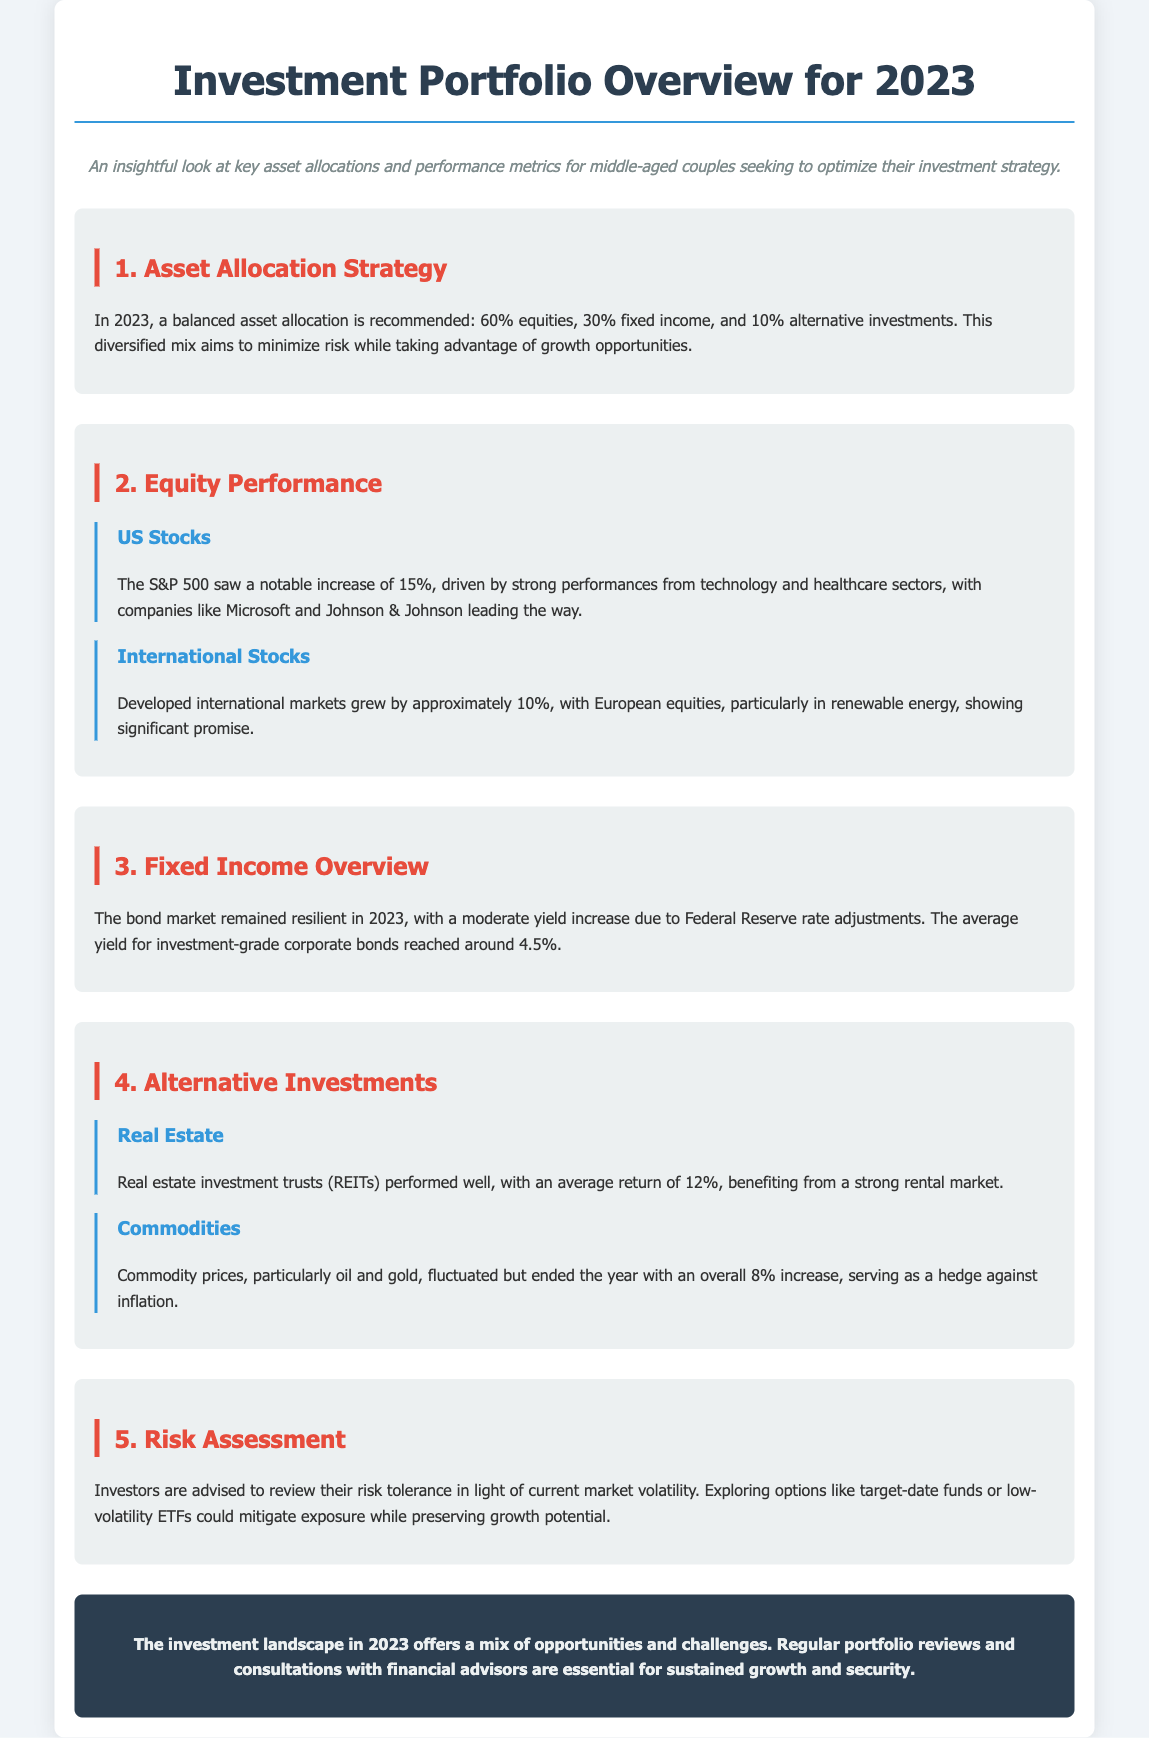What is the recommended asset allocation for 2023? The recommended asset allocation is a diversified mix of 60% equities, 30% fixed income, and 10% alternative investments.
Answer: 60% equities, 30% fixed income, 10% alternative investments What was the increase percentage for US Stocks in 2023? The increase for US Stocks, specifically the S&P 500, was 15%.
Answer: 15% What was the average yield for investment-grade corporate bonds in 2023? The average yield for investment-grade corporate bonds reached around 4.5%.
Answer: 4.5% What was the average return for Real Estate Investment Trusts (REITs) in 2023? The average return for REITs in 2023 was 12%.
Answer: 12% What is advised for investors regarding market volatility? Investors are advised to review their risk tolerance in light of current market volatility.
Answer: Review risk tolerance What sectors drove the strong performances of US Stocks in 2023? The technology and healthcare sectors drove the strong performances of US Stocks.
Answer: Technology and healthcare sectors How much did international markets grow by in 2023? Developed international markets grew by approximately 10%.
Answer: 10% What could mitigate exposure while preserving growth potential? Exploring options like target-date funds or low-volatility ETFs could mitigate exposure while preserving growth potential.
Answer: Target-date funds or low-volatility ETFs 